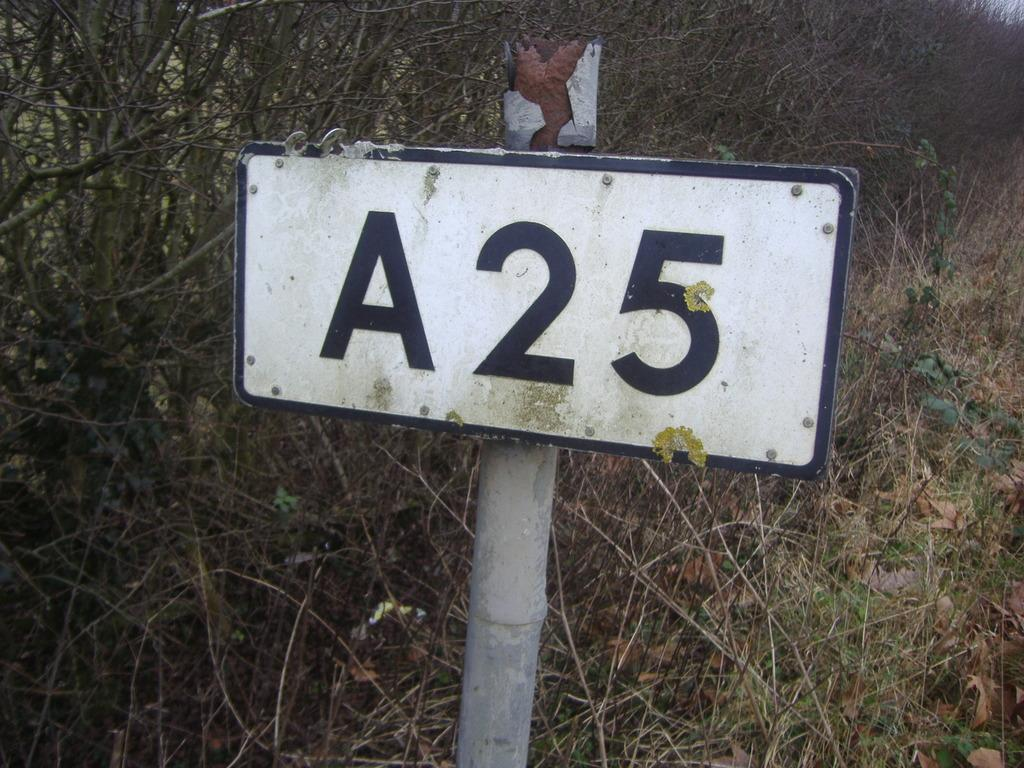Provide a one-sentence caption for the provided image. An old worn out sign on a rusted metal pole that reads A25. 